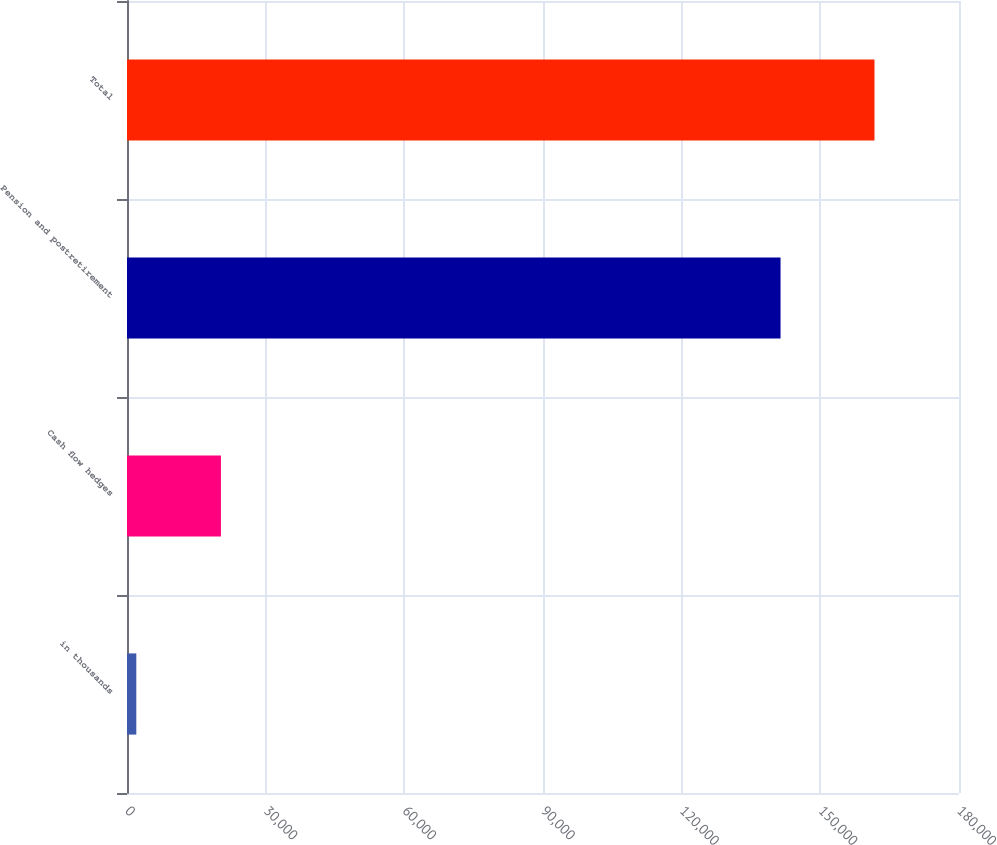<chart> <loc_0><loc_0><loc_500><loc_500><bar_chart><fcel>in thousands<fcel>Cash flow hedges<fcel>Pension and postretirement<fcel>Total<nl><fcel>2014<fcel>20322<fcel>141392<fcel>161714<nl></chart> 